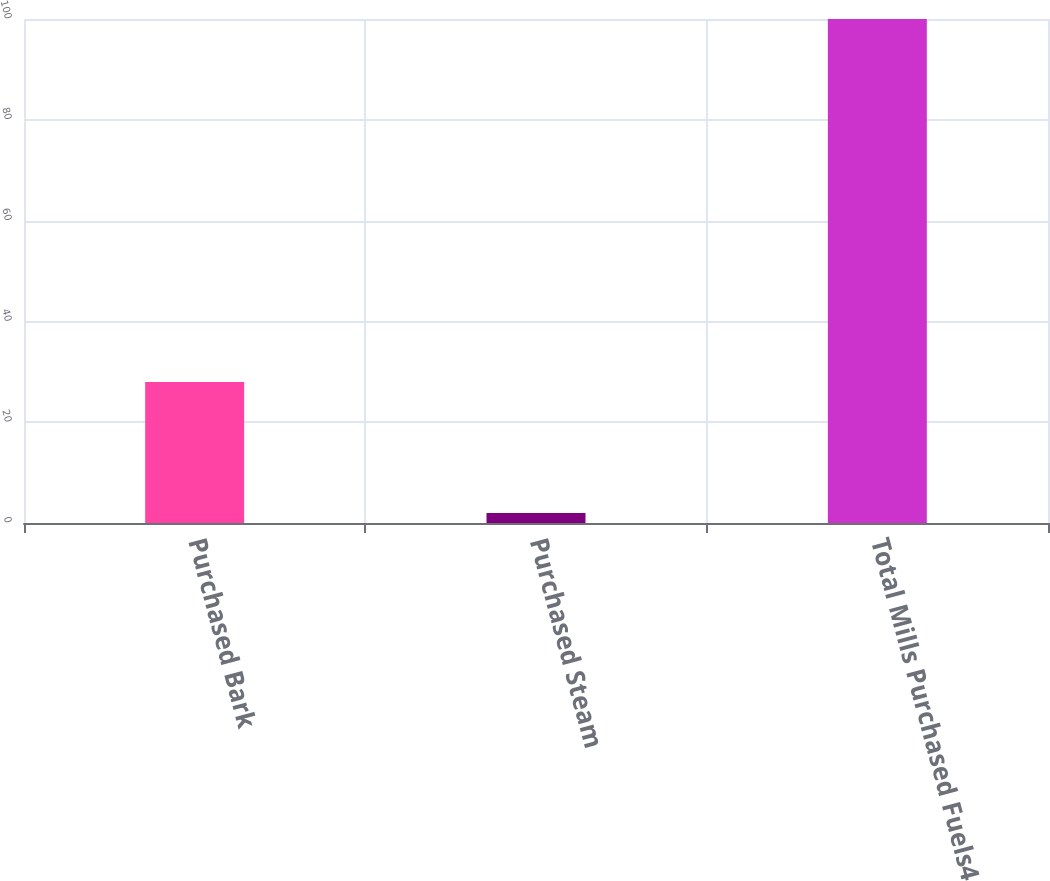Convert chart to OTSL. <chart><loc_0><loc_0><loc_500><loc_500><bar_chart><fcel>Purchased Bark<fcel>Purchased Steam<fcel>Total Mills Purchased Fuels4<nl><fcel>28<fcel>2<fcel>100<nl></chart> 